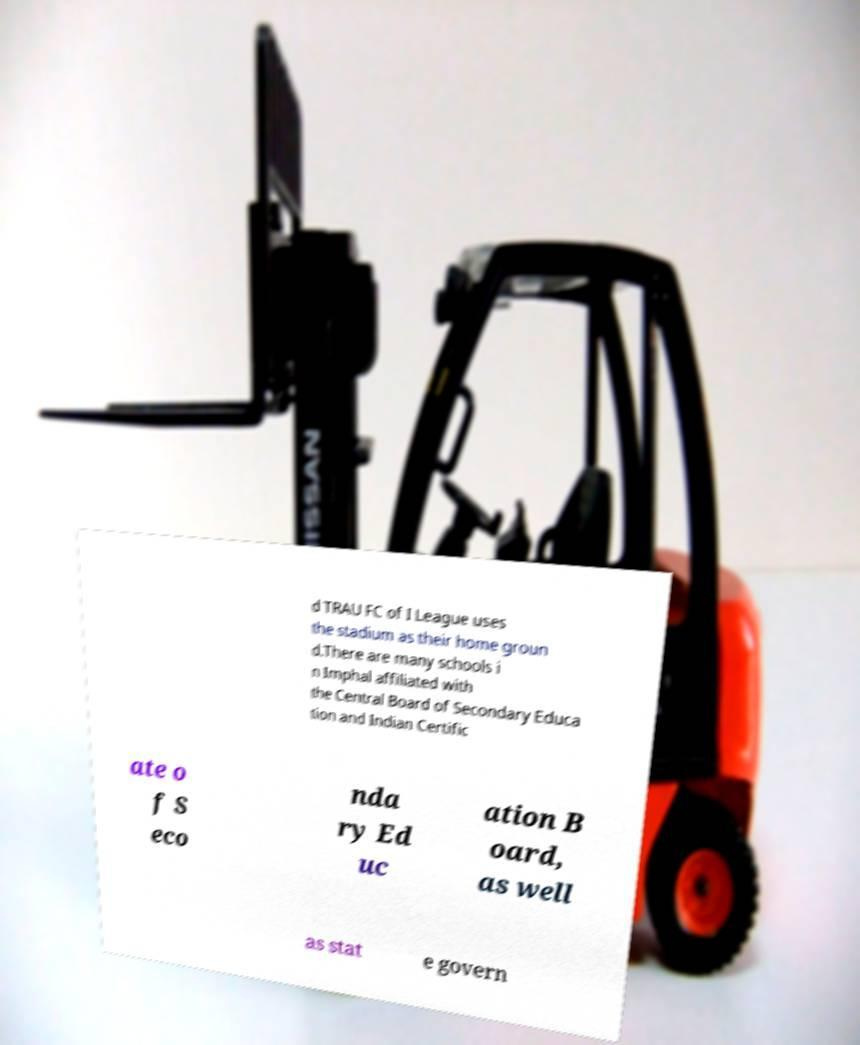Can you read and provide the text displayed in the image?This photo seems to have some interesting text. Can you extract and type it out for me? d TRAU FC of I League uses the stadium as their home groun d.There are many schools i n Imphal affiliated with the Central Board of Secondary Educa tion and Indian Certific ate o f S eco nda ry Ed uc ation B oard, as well as stat e govern 